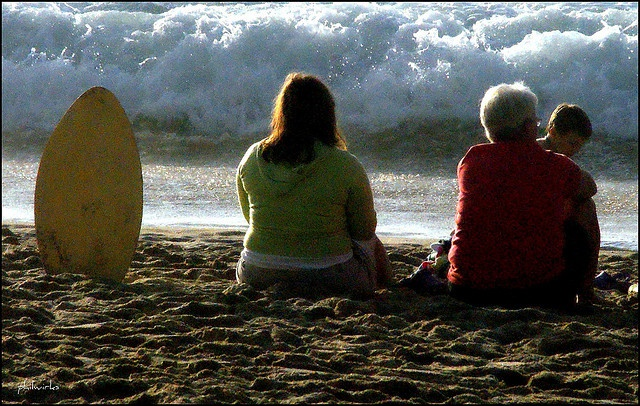Describe the objects in this image and their specific colors. I can see people in black, gray, and darkgreen tones, people in black, maroon, gray, and white tones, surfboard in black, olive, and darkgreen tones, and people in black, maroon, gray, and tan tones in this image. 